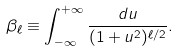<formula> <loc_0><loc_0><loc_500><loc_500>\beta _ { \ell } \equiv \int _ { - \infty } ^ { + \infty } \frac { d u } { ( 1 + u ^ { 2 } ) ^ { \ell / 2 } } .</formula> 